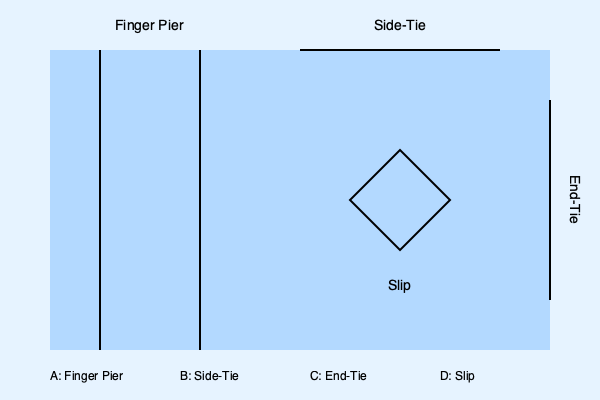Based on the top-view layout of a marina, identify which type of berth would be most suitable for a 50-foot yacht with a beam of 15 feet, considering ease of access and protection from wind and waves. To determine the most suitable berth for a 50-foot yacht with a 15-foot beam, let's analyze each berth type:

1. Finger Pier (A):
   - Pros: Provides good access from the side and protection on one side.
   - Cons: May not be wide enough for a 15-foot beam yacht.

2. Side-Tie (B):
   - Pros: Easy access for larger boats, flexible length accommodation.
   - Cons: Limited protection from wind and waves, may require more fenders.

3. End-Tie (C):
   - Pros: Can accommodate longer boats, easy bow or stern access.
   - Cons: Limited protection from wind and waves, challenging side access.

4. Slip (D):
   - Pros: Excellent protection from wind and waves, easy access from all sides.
   - Cons: Fixed size may limit larger boats.

For a 50-foot yacht with a 15-foot beam:
- The slip (D) would provide the best protection and access.
- It can accommodate the yacht's length and width comfortably.
- Offers protection on three sides, reducing the impact of wind and waves.
- Allows for easy maneuvering during docking and undocking.

Therefore, the slip (D) is the most suitable berth type for this yacht, balancing protection, access, and size requirements.
Answer: Slip (D) 